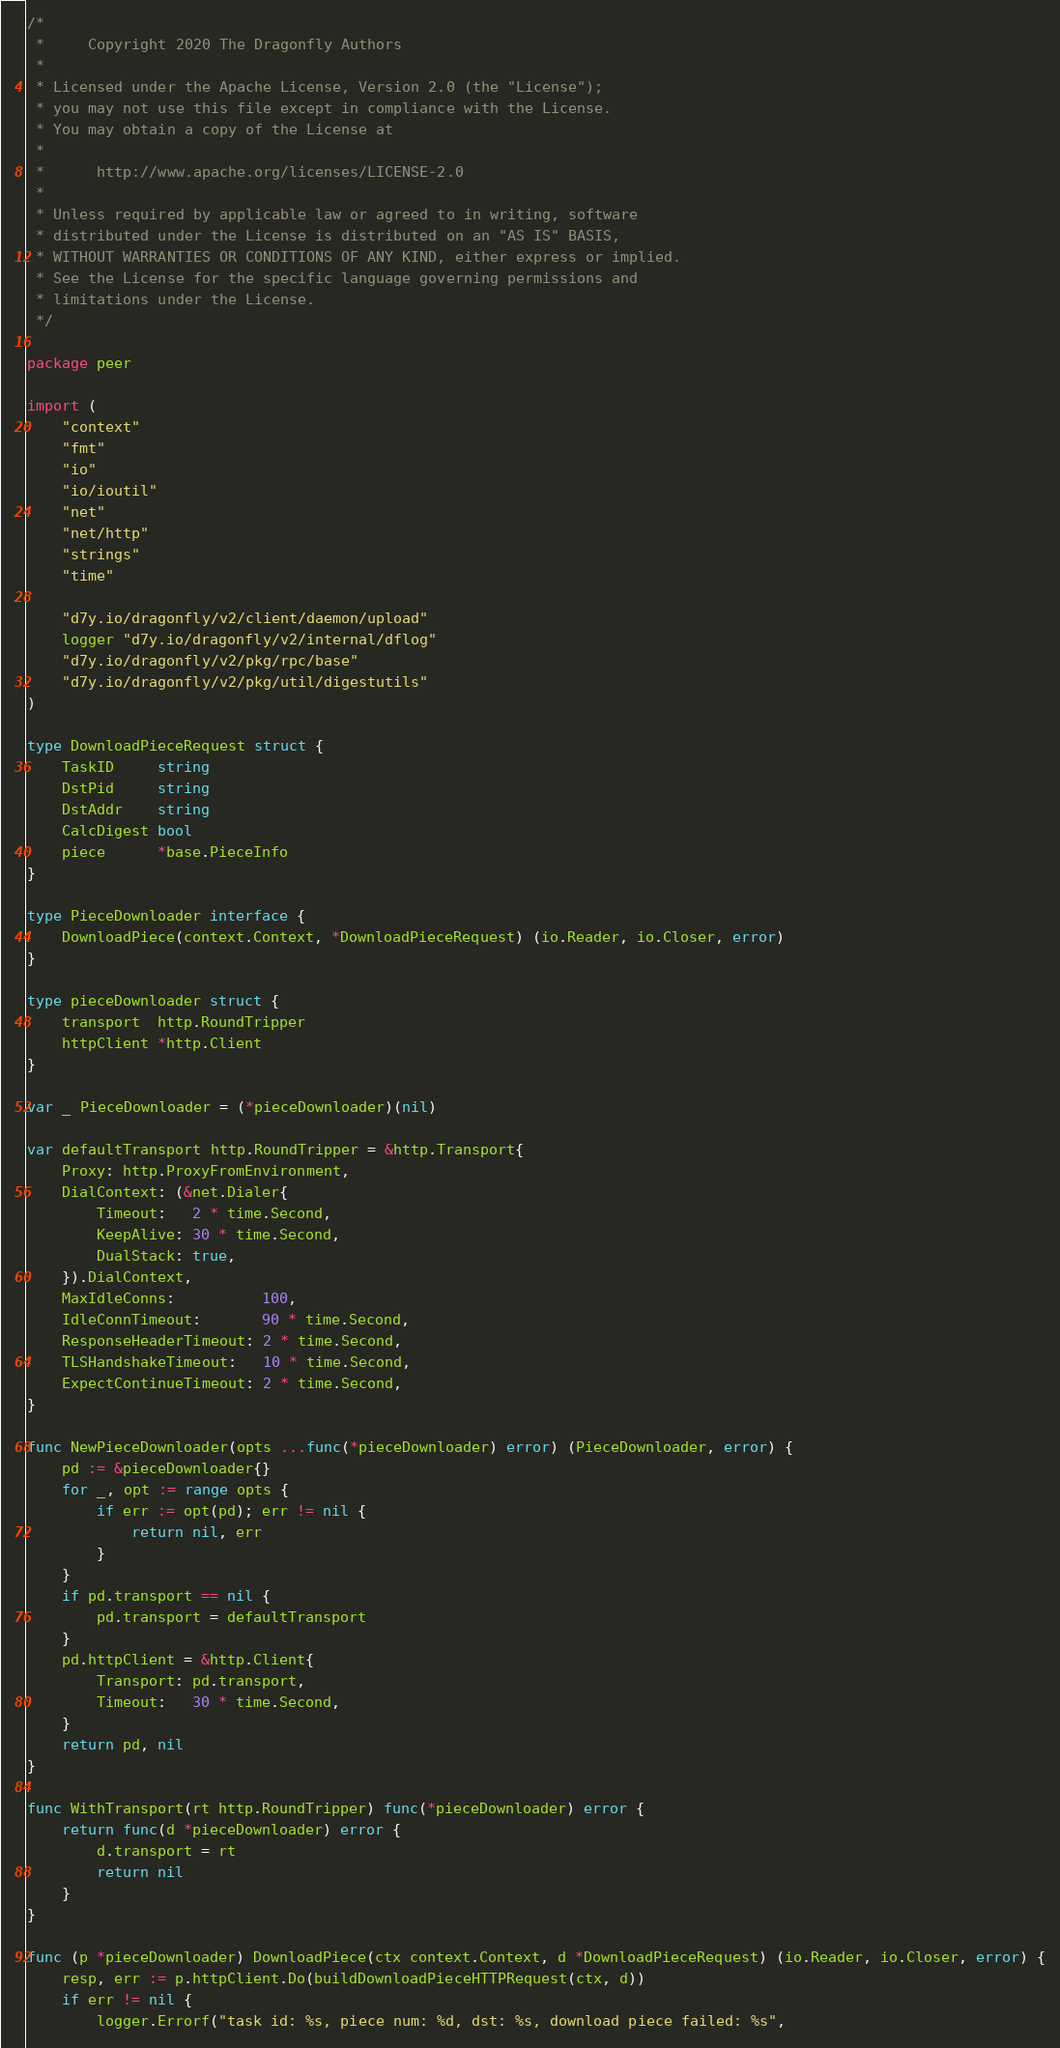Convert code to text. <code><loc_0><loc_0><loc_500><loc_500><_Go_>/*
 *     Copyright 2020 The Dragonfly Authors
 *
 * Licensed under the Apache License, Version 2.0 (the "License");
 * you may not use this file except in compliance with the License.
 * You may obtain a copy of the License at
 *
 *      http://www.apache.org/licenses/LICENSE-2.0
 *
 * Unless required by applicable law or agreed to in writing, software
 * distributed under the License is distributed on an "AS IS" BASIS,
 * WITHOUT WARRANTIES OR CONDITIONS OF ANY KIND, either express or implied.
 * See the License for the specific language governing permissions and
 * limitations under the License.
 */

package peer

import (
	"context"
	"fmt"
	"io"
	"io/ioutil"
	"net"
	"net/http"
	"strings"
	"time"

	"d7y.io/dragonfly/v2/client/daemon/upload"
	logger "d7y.io/dragonfly/v2/internal/dflog"
	"d7y.io/dragonfly/v2/pkg/rpc/base"
	"d7y.io/dragonfly/v2/pkg/util/digestutils"
)

type DownloadPieceRequest struct {
	TaskID     string
	DstPid     string
	DstAddr    string
	CalcDigest bool
	piece      *base.PieceInfo
}

type PieceDownloader interface {
	DownloadPiece(context.Context, *DownloadPieceRequest) (io.Reader, io.Closer, error)
}

type pieceDownloader struct {
	transport  http.RoundTripper
	httpClient *http.Client
}

var _ PieceDownloader = (*pieceDownloader)(nil)

var defaultTransport http.RoundTripper = &http.Transport{
	Proxy: http.ProxyFromEnvironment,
	DialContext: (&net.Dialer{
		Timeout:   2 * time.Second,
		KeepAlive: 30 * time.Second,
		DualStack: true,
	}).DialContext,
	MaxIdleConns:          100,
	IdleConnTimeout:       90 * time.Second,
	ResponseHeaderTimeout: 2 * time.Second,
	TLSHandshakeTimeout:   10 * time.Second,
	ExpectContinueTimeout: 2 * time.Second,
}

func NewPieceDownloader(opts ...func(*pieceDownloader) error) (PieceDownloader, error) {
	pd := &pieceDownloader{}
	for _, opt := range opts {
		if err := opt(pd); err != nil {
			return nil, err
		}
	}
	if pd.transport == nil {
		pd.transport = defaultTransport
	}
	pd.httpClient = &http.Client{
		Transport: pd.transport,
		Timeout:   30 * time.Second,
	}
	return pd, nil
}

func WithTransport(rt http.RoundTripper) func(*pieceDownloader) error {
	return func(d *pieceDownloader) error {
		d.transport = rt
		return nil
	}
}

func (p *pieceDownloader) DownloadPiece(ctx context.Context, d *DownloadPieceRequest) (io.Reader, io.Closer, error) {
	resp, err := p.httpClient.Do(buildDownloadPieceHTTPRequest(ctx, d))
	if err != nil {
		logger.Errorf("task id: %s, piece num: %d, dst: %s, download piece failed: %s",</code> 